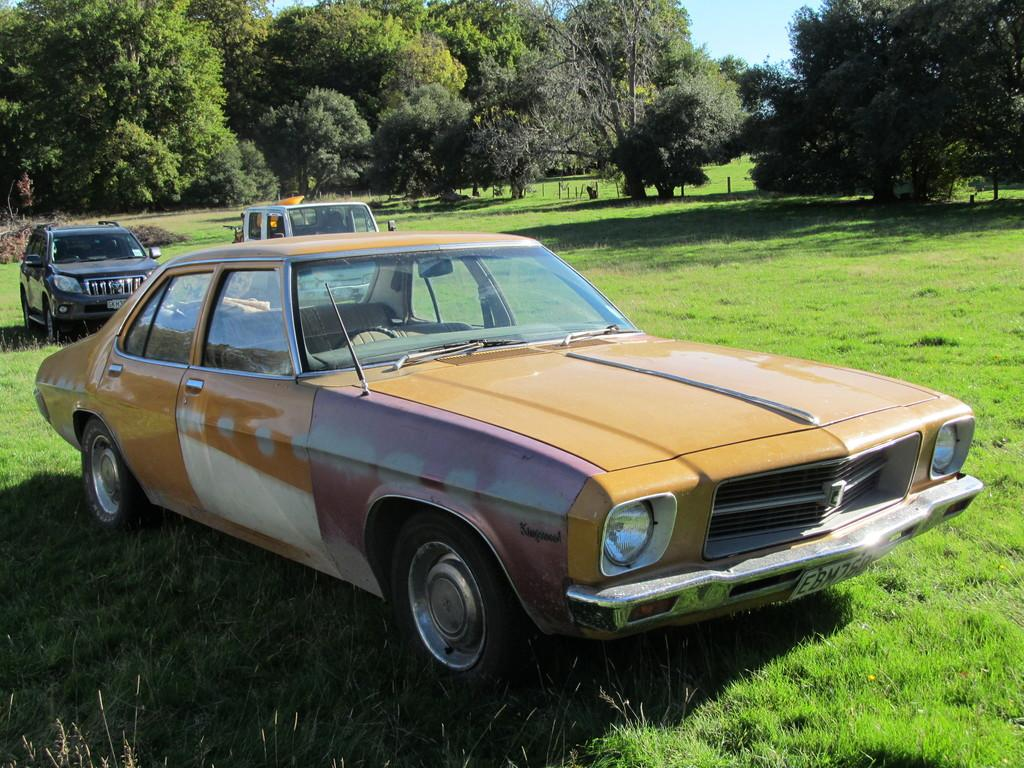What objects are placed on the ground in the image? There are cars placed on the ground in the image. What type of vegetation can be seen in the image? There is grass visible in the image. What structures are present in the image? There are poles in the image. What natural feature is visible in the image? There is a group of trees in the image. What is visible in the sky in the image? The sky is visible in the image, and it looks cloudy. How many dogs are sitting on the rock in the image? There are no dogs or rocks present in the image. 